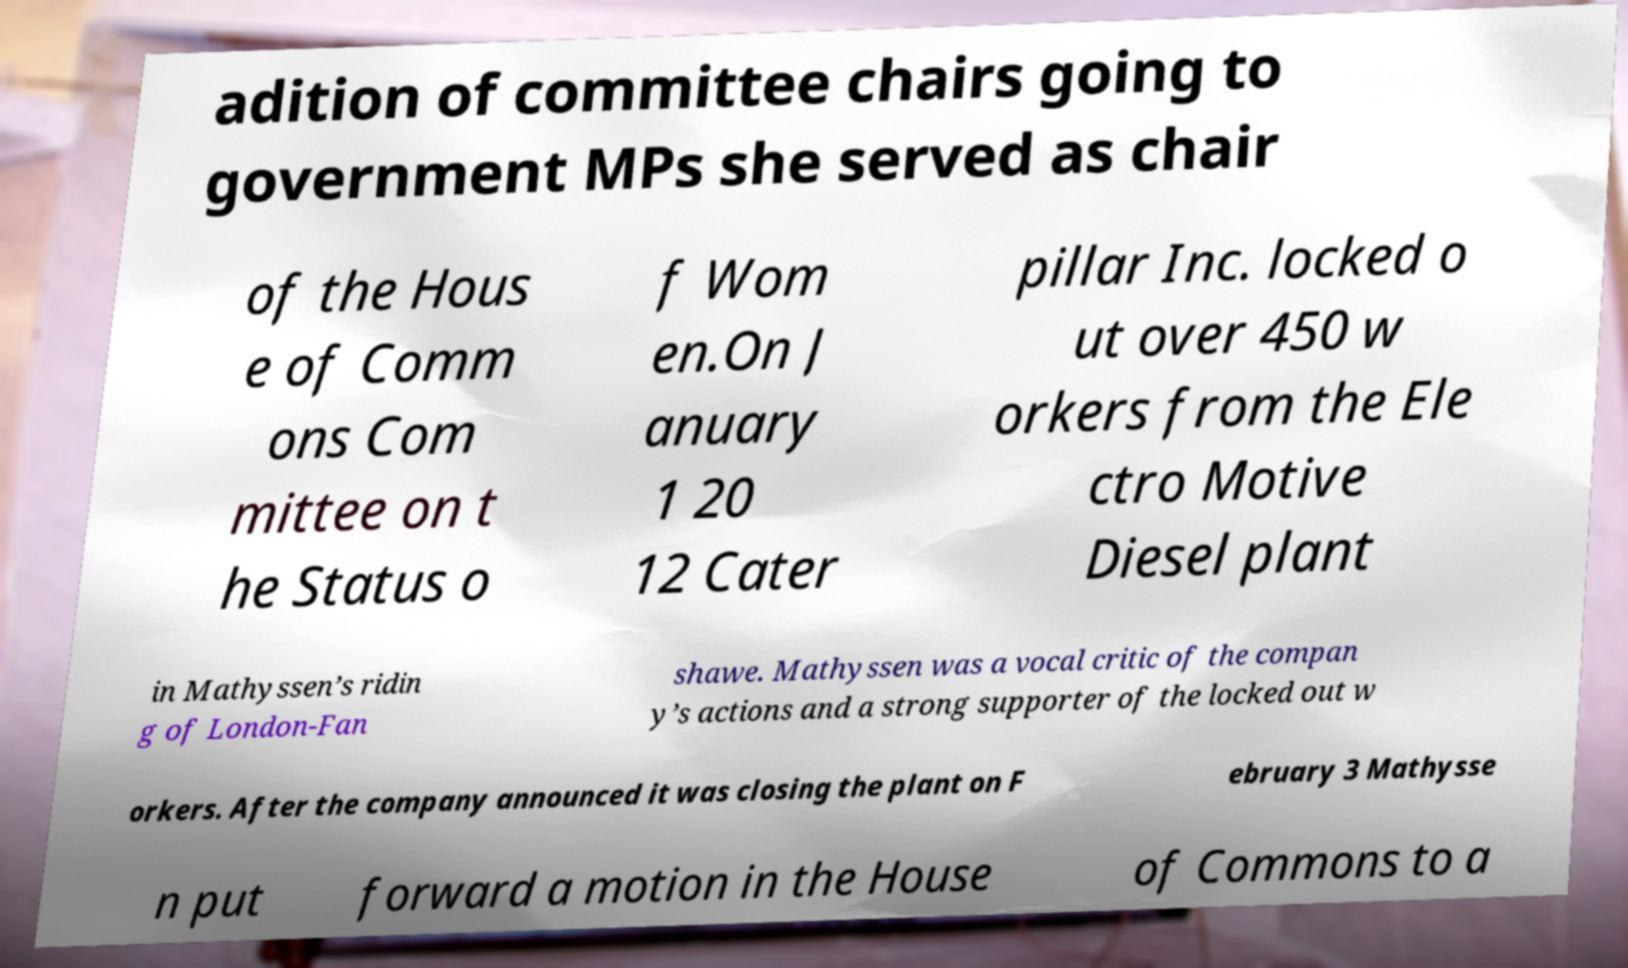Can you read and provide the text displayed in the image?This photo seems to have some interesting text. Can you extract and type it out for me? adition of committee chairs going to government MPs she served as chair of the Hous e of Comm ons Com mittee on t he Status o f Wom en.On J anuary 1 20 12 Cater pillar Inc. locked o ut over 450 w orkers from the Ele ctro Motive Diesel plant in Mathyssen’s ridin g of London-Fan shawe. Mathyssen was a vocal critic of the compan y’s actions and a strong supporter of the locked out w orkers. After the company announced it was closing the plant on F ebruary 3 Mathysse n put forward a motion in the House of Commons to a 